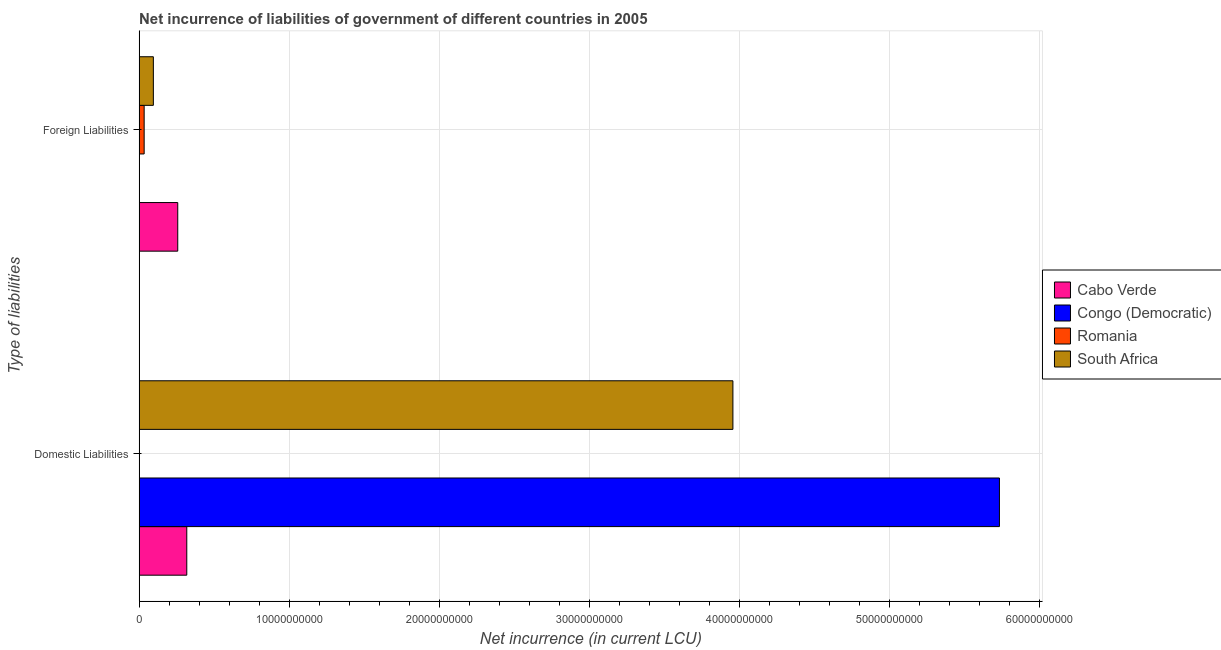Are the number of bars on each tick of the Y-axis equal?
Provide a succinct answer. Yes. How many bars are there on the 1st tick from the top?
Offer a very short reply. 3. What is the label of the 1st group of bars from the top?
Provide a succinct answer. Foreign Liabilities. What is the net incurrence of domestic liabilities in Congo (Democratic)?
Your answer should be compact. 5.74e+1. Across all countries, what is the maximum net incurrence of domestic liabilities?
Your response must be concise. 5.74e+1. In which country was the net incurrence of foreign liabilities maximum?
Keep it short and to the point. Cabo Verde. What is the total net incurrence of domestic liabilities in the graph?
Make the answer very short. 1.00e+11. What is the difference between the net incurrence of foreign liabilities in Romania and that in Cabo Verde?
Provide a short and direct response. -2.24e+09. What is the difference between the net incurrence of domestic liabilities in South Africa and the net incurrence of foreign liabilities in Congo (Democratic)?
Make the answer very short. 3.96e+1. What is the average net incurrence of domestic liabilities per country?
Keep it short and to the point. 2.50e+1. What is the difference between the net incurrence of foreign liabilities and net incurrence of domestic liabilities in South Africa?
Your response must be concise. -3.86e+1. In how many countries, is the net incurrence of foreign liabilities greater than 36000000000 LCU?
Give a very brief answer. 0. What is the ratio of the net incurrence of domestic liabilities in Congo (Democratic) to that in Cabo Verde?
Your answer should be very brief. 18.04. Is the net incurrence of foreign liabilities in Cabo Verde less than that in South Africa?
Ensure brevity in your answer.  No. How many countries are there in the graph?
Your answer should be compact. 4. What is the difference between two consecutive major ticks on the X-axis?
Make the answer very short. 1.00e+1. Are the values on the major ticks of X-axis written in scientific E-notation?
Your answer should be compact. No. How many legend labels are there?
Provide a succinct answer. 4. How are the legend labels stacked?
Offer a terse response. Vertical. What is the title of the graph?
Provide a succinct answer. Net incurrence of liabilities of government of different countries in 2005. Does "Ecuador" appear as one of the legend labels in the graph?
Give a very brief answer. No. What is the label or title of the X-axis?
Offer a very short reply. Net incurrence (in current LCU). What is the label or title of the Y-axis?
Provide a succinct answer. Type of liabilities. What is the Net incurrence (in current LCU) in Cabo Verde in Domestic Liabilities?
Offer a very short reply. 3.18e+09. What is the Net incurrence (in current LCU) in Congo (Democratic) in Domestic Liabilities?
Make the answer very short. 5.74e+1. What is the Net incurrence (in current LCU) in Romania in Domestic Liabilities?
Offer a terse response. 0. What is the Net incurrence (in current LCU) in South Africa in Domestic Liabilities?
Keep it short and to the point. 3.96e+1. What is the Net incurrence (in current LCU) of Cabo Verde in Foreign Liabilities?
Your answer should be compact. 2.58e+09. What is the Net incurrence (in current LCU) of Romania in Foreign Liabilities?
Keep it short and to the point. 3.37e+08. What is the Net incurrence (in current LCU) of South Africa in Foreign Liabilities?
Keep it short and to the point. 9.50e+08. Across all Type of liabilities, what is the maximum Net incurrence (in current LCU) of Cabo Verde?
Offer a very short reply. 3.18e+09. Across all Type of liabilities, what is the maximum Net incurrence (in current LCU) in Congo (Democratic)?
Provide a succinct answer. 5.74e+1. Across all Type of liabilities, what is the maximum Net incurrence (in current LCU) of Romania?
Your answer should be very brief. 3.37e+08. Across all Type of liabilities, what is the maximum Net incurrence (in current LCU) of South Africa?
Your response must be concise. 3.96e+1. Across all Type of liabilities, what is the minimum Net incurrence (in current LCU) of Cabo Verde?
Your answer should be compact. 2.58e+09. Across all Type of liabilities, what is the minimum Net incurrence (in current LCU) of Congo (Democratic)?
Your answer should be compact. 0. Across all Type of liabilities, what is the minimum Net incurrence (in current LCU) in South Africa?
Keep it short and to the point. 9.50e+08. What is the total Net incurrence (in current LCU) of Cabo Verde in the graph?
Your answer should be very brief. 5.76e+09. What is the total Net incurrence (in current LCU) of Congo (Democratic) in the graph?
Offer a terse response. 5.74e+1. What is the total Net incurrence (in current LCU) in Romania in the graph?
Keep it short and to the point. 3.37e+08. What is the total Net incurrence (in current LCU) in South Africa in the graph?
Ensure brevity in your answer.  4.05e+1. What is the difference between the Net incurrence (in current LCU) of Cabo Verde in Domestic Liabilities and that in Foreign Liabilities?
Provide a short and direct response. 6.03e+08. What is the difference between the Net incurrence (in current LCU) of South Africa in Domestic Liabilities and that in Foreign Liabilities?
Your answer should be very brief. 3.86e+1. What is the difference between the Net incurrence (in current LCU) in Cabo Verde in Domestic Liabilities and the Net incurrence (in current LCU) in Romania in Foreign Liabilities?
Offer a very short reply. 2.84e+09. What is the difference between the Net incurrence (in current LCU) of Cabo Verde in Domestic Liabilities and the Net incurrence (in current LCU) of South Africa in Foreign Liabilities?
Provide a short and direct response. 2.23e+09. What is the difference between the Net incurrence (in current LCU) of Congo (Democratic) in Domestic Liabilities and the Net incurrence (in current LCU) of Romania in Foreign Liabilities?
Keep it short and to the point. 5.70e+1. What is the difference between the Net incurrence (in current LCU) of Congo (Democratic) in Domestic Liabilities and the Net incurrence (in current LCU) of South Africa in Foreign Liabilities?
Give a very brief answer. 5.64e+1. What is the average Net incurrence (in current LCU) of Cabo Verde per Type of liabilities?
Ensure brevity in your answer.  2.88e+09. What is the average Net incurrence (in current LCU) of Congo (Democratic) per Type of liabilities?
Provide a short and direct response. 2.87e+1. What is the average Net incurrence (in current LCU) in Romania per Type of liabilities?
Ensure brevity in your answer.  1.68e+08. What is the average Net incurrence (in current LCU) in South Africa per Type of liabilities?
Ensure brevity in your answer.  2.03e+1. What is the difference between the Net incurrence (in current LCU) of Cabo Verde and Net incurrence (in current LCU) of Congo (Democratic) in Domestic Liabilities?
Make the answer very short. -5.42e+1. What is the difference between the Net incurrence (in current LCU) of Cabo Verde and Net incurrence (in current LCU) of South Africa in Domestic Liabilities?
Offer a terse response. -3.64e+1. What is the difference between the Net incurrence (in current LCU) of Congo (Democratic) and Net incurrence (in current LCU) of South Africa in Domestic Liabilities?
Provide a short and direct response. 1.78e+1. What is the difference between the Net incurrence (in current LCU) of Cabo Verde and Net incurrence (in current LCU) of Romania in Foreign Liabilities?
Offer a terse response. 2.24e+09. What is the difference between the Net incurrence (in current LCU) of Cabo Verde and Net incurrence (in current LCU) of South Africa in Foreign Liabilities?
Provide a succinct answer. 1.63e+09. What is the difference between the Net incurrence (in current LCU) in Romania and Net incurrence (in current LCU) in South Africa in Foreign Liabilities?
Your answer should be compact. -6.13e+08. What is the ratio of the Net incurrence (in current LCU) of Cabo Verde in Domestic Liabilities to that in Foreign Liabilities?
Offer a terse response. 1.23. What is the ratio of the Net incurrence (in current LCU) of South Africa in Domestic Liabilities to that in Foreign Liabilities?
Keep it short and to the point. 41.67. What is the difference between the highest and the second highest Net incurrence (in current LCU) in Cabo Verde?
Ensure brevity in your answer.  6.03e+08. What is the difference between the highest and the second highest Net incurrence (in current LCU) of South Africa?
Make the answer very short. 3.86e+1. What is the difference between the highest and the lowest Net incurrence (in current LCU) of Cabo Verde?
Provide a succinct answer. 6.03e+08. What is the difference between the highest and the lowest Net incurrence (in current LCU) in Congo (Democratic)?
Make the answer very short. 5.74e+1. What is the difference between the highest and the lowest Net incurrence (in current LCU) of Romania?
Offer a very short reply. 3.37e+08. What is the difference between the highest and the lowest Net incurrence (in current LCU) of South Africa?
Give a very brief answer. 3.86e+1. 